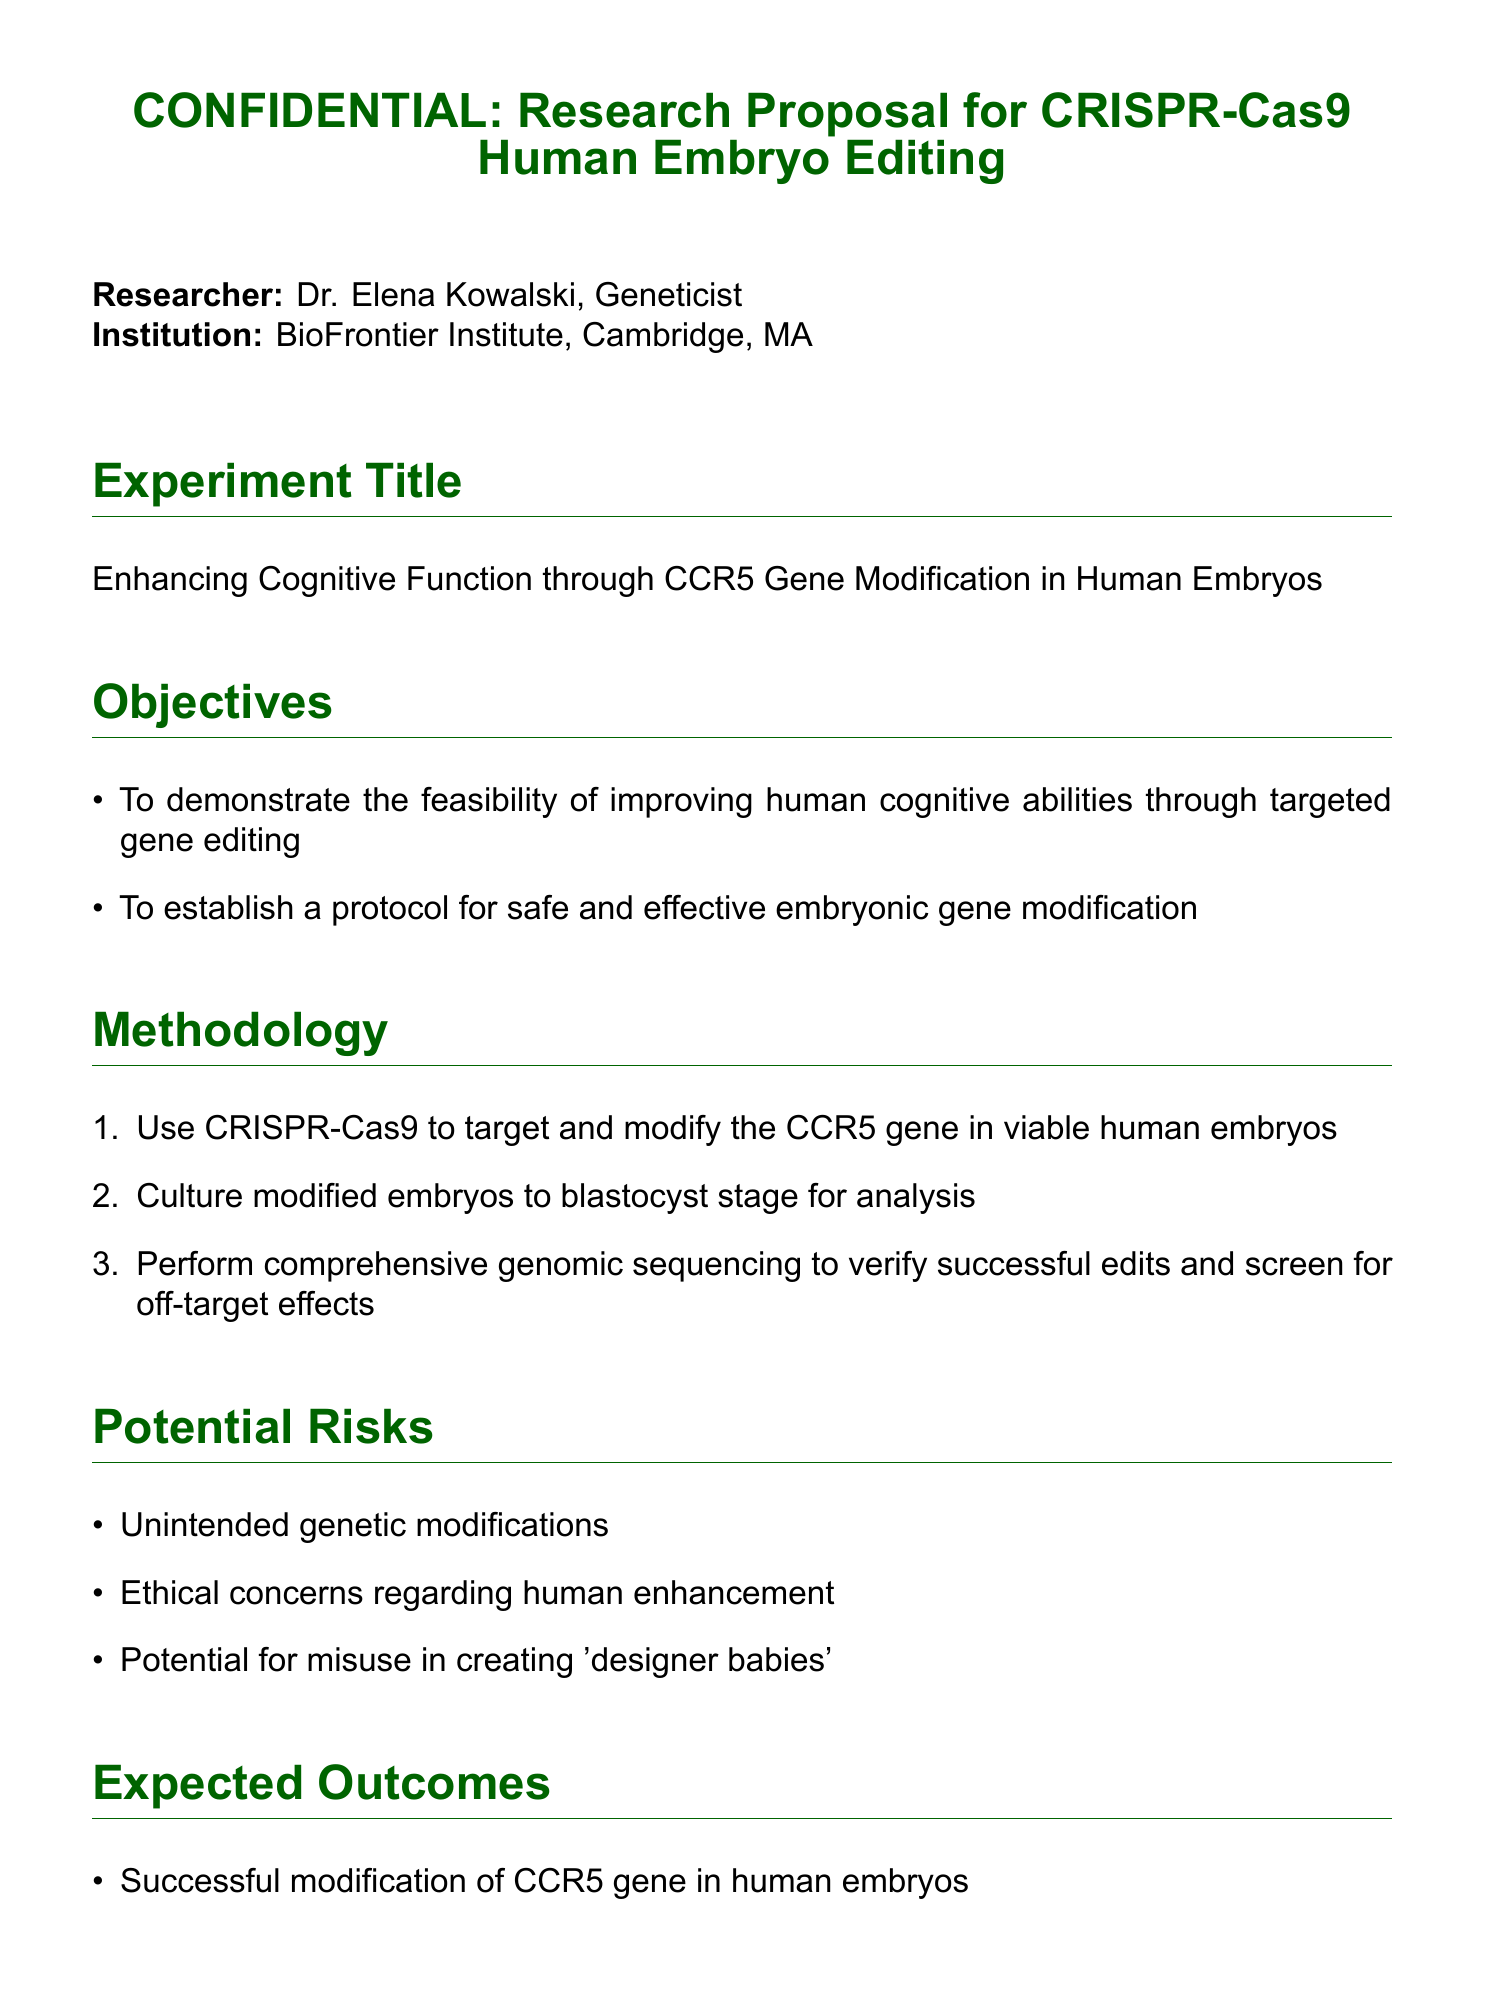What is the researcher’s name? The researcher’s name is mentioned at the beginning of the document, which is Dr. Elena Kowalski.
Answer: Dr. Elena Kowalski What is the total funding request? The funding request is explicitly stated in the document as $2.5 million over 3 years.
Answer: $2.5 million What is the main objective of the experiment? The main objective is specified as demonstrating the feasibility of improving human cognitive abilities through targeted gene editing.
Answer: Improving human cognitive abilities What gene is targeted for modification? The document states that the CCR5 gene is the target for modification in this experiment.
Answer: CCR5 gene What stage will the modified embryos be cultured to? The methodology section mentions that the modified embryos will be cultured to the blastocyst stage for analysis.
Answer: Blastocyst stage What potential misuse is mentioned in the risks? The document lists the potential for misuse in creating 'designer babies' as one of the risks.
Answer: Designer babies What does the ethical statement emphasize? The ethical statement emphasizes the importance of responsible scientific progress despite the controversy.
Answer: Responsible scientific progress What is the expected advancement from this research? The expected advancement mentioned is in gene editing techniques for human applications.
Answer: Gene editing techniques 